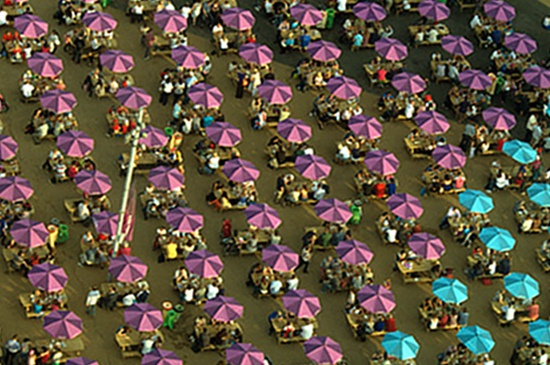Describe the objects in this image and their specific colors. I can see people in darkgreen, black, olive, maroon, and gray tones, dining table in darkgreen, olive, black, and maroon tones, umbrella in darkgreen, purple, violet, and brown tones, umbrella in darkgreen, lightpink, and purple tones, and umbrella in darkgreen, brown, purple, and lightpink tones in this image. 